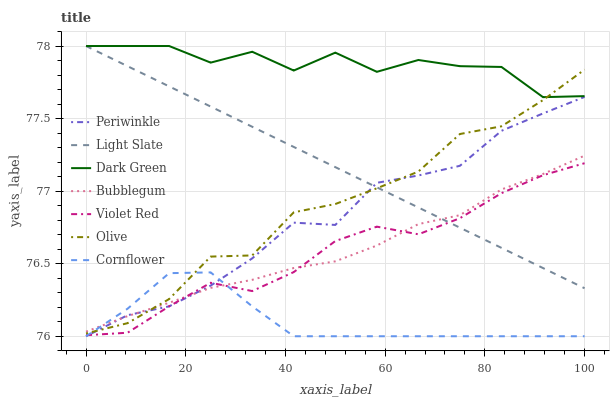Does Cornflower have the minimum area under the curve?
Answer yes or no. Yes. Does Dark Green have the maximum area under the curve?
Answer yes or no. Yes. Does Violet Red have the minimum area under the curve?
Answer yes or no. No. Does Violet Red have the maximum area under the curve?
Answer yes or no. No. Is Light Slate the smoothest?
Answer yes or no. Yes. Is Dark Green the roughest?
Answer yes or no. Yes. Is Violet Red the smoothest?
Answer yes or no. No. Is Violet Red the roughest?
Answer yes or no. No. Does Cornflower have the lowest value?
Answer yes or no. Yes. Does Violet Red have the lowest value?
Answer yes or no. No. Does Dark Green have the highest value?
Answer yes or no. Yes. Does Violet Red have the highest value?
Answer yes or no. No. Is Cornflower less than Dark Green?
Answer yes or no. Yes. Is Dark Green greater than Periwinkle?
Answer yes or no. Yes. Does Violet Red intersect Periwinkle?
Answer yes or no. Yes. Is Violet Red less than Periwinkle?
Answer yes or no. No. Is Violet Red greater than Periwinkle?
Answer yes or no. No. Does Cornflower intersect Dark Green?
Answer yes or no. No. 